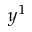<formula> <loc_0><loc_0><loc_500><loc_500>y ^ { 1 }</formula> 